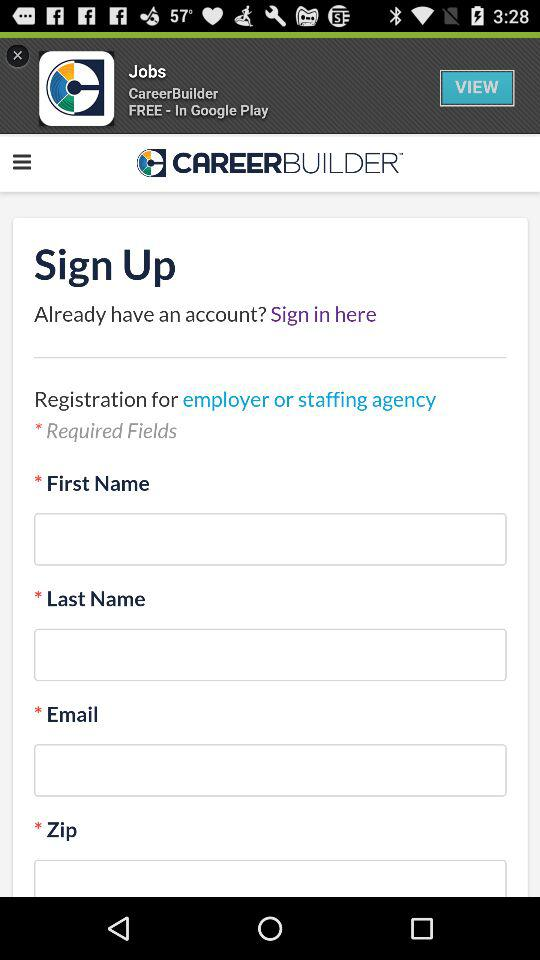What is the application name? The application name is "CAREER BUILDER". 